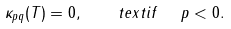Convert formula to latex. <formula><loc_0><loc_0><loc_500><loc_500>\kappa _ { p q } ( T ) = 0 , \quad t e x t { i f } \ \ p < 0 .</formula> 